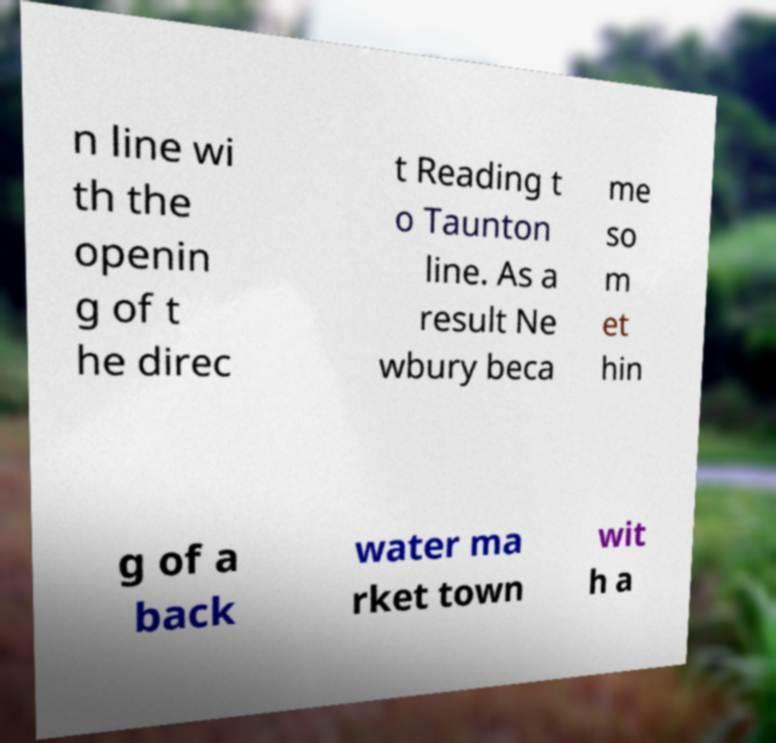I need the written content from this picture converted into text. Can you do that? n line wi th the openin g of t he direc t Reading t o Taunton line. As a result Ne wbury beca me so m et hin g of a back water ma rket town wit h a 